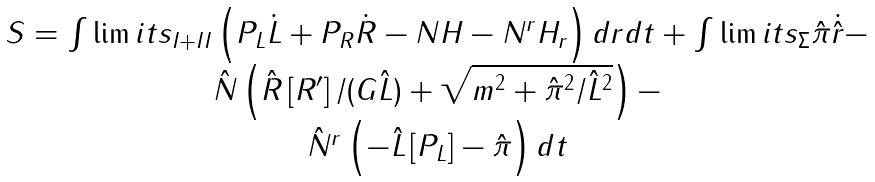<formula> <loc_0><loc_0><loc_500><loc_500>\begin{array} { c } S = \int \lim i t s _ { I + I I } \left ( P _ { L } \dot { L } + P _ { R } \dot { R } - N H - N ^ { r } H _ { r } \right ) d r d t + \int \lim i t s _ { \Sigma } \hat { \pi } \dot { \hat { r } } - \\ \hat { N } \left ( \hat { R } \left [ R ^ { \prime } \right ] / ( G \hat { L } ) + \sqrt { m ^ { 2 } + \hat { \pi } ^ { 2 } / \hat { L } ^ { 2 } } \right ) - \\ \hat { N } ^ { r } \left ( - \hat { L } \left [ P _ { L } \right ] - \hat { \pi } \right ) d t \end{array}</formula> 